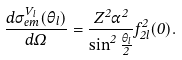<formula> <loc_0><loc_0><loc_500><loc_500>\frac { d \sigma _ { e m } ^ { V _ { l } } ( \theta _ { l } ) } { d \Omega } = \frac { Z ^ { 2 } \alpha ^ { 2 } } { \sin ^ { 2 } \frac { \theta _ { l } } { 2 } } f _ { 2 l } ^ { 2 } ( 0 ) .</formula> 